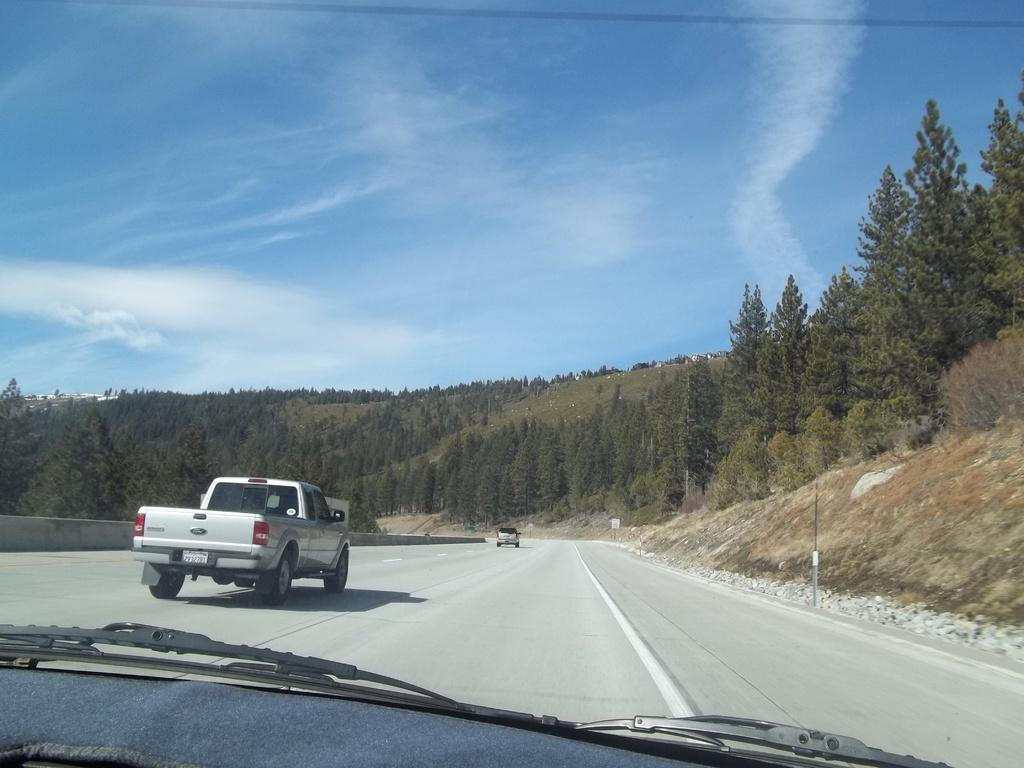What is the main subject of the image? The image shows a vehicle mirror. What can be seen through the mirror? Two other vehicles are visible on the road through the mirror. What is visible in the background of the image? There are mountains in the background. What type of vegetation is present on the mountains? Trees and plants are visible on the mountains. How many geese are flying over the mountains in the image? There are no geese visible in the image; it only shows a vehicle mirror, two other vehicles on the road, and mountains with trees and plants. What type of grass is growing on the mountains in the image? There is no grass visible in the image; it only shows a vehicle mirror, two other vehicles on the road, and mountains with trees and plants. 